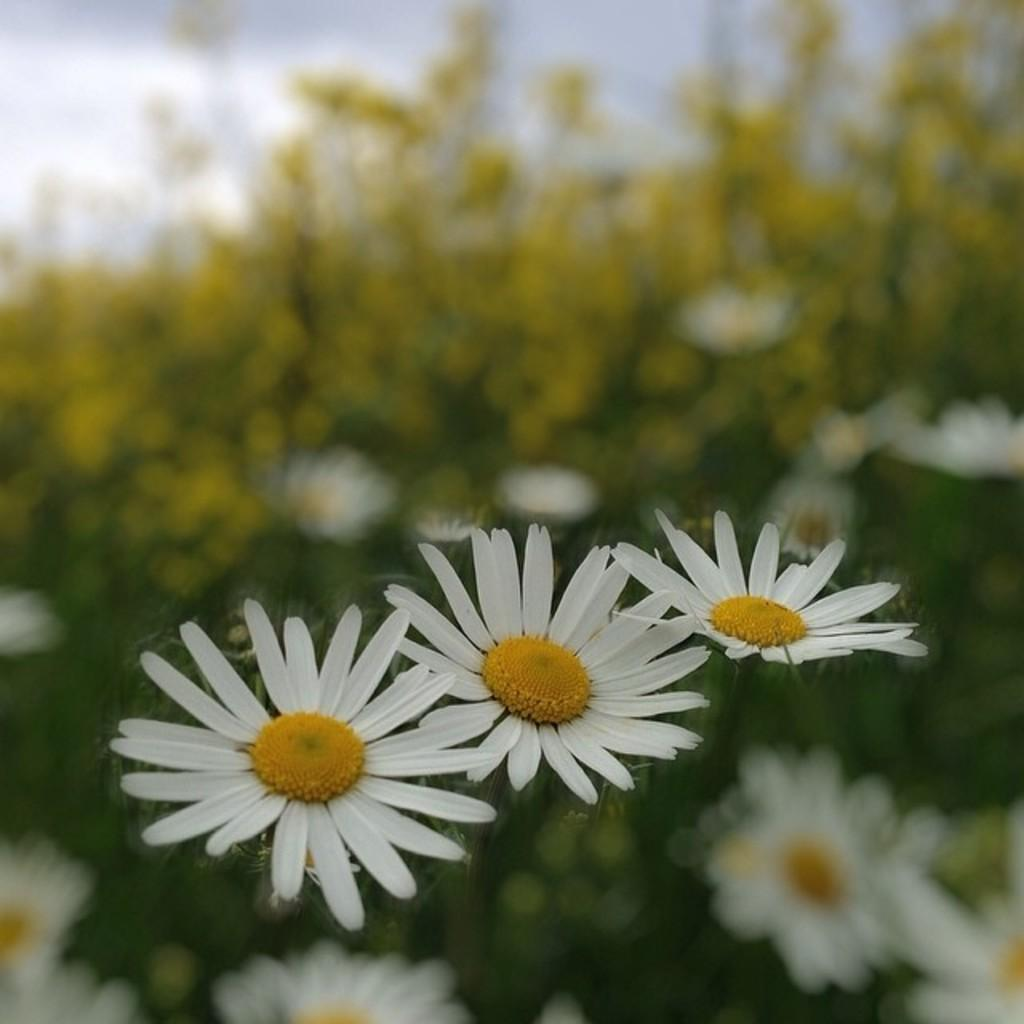What type of objects are present in the image? There are flowers in the image. What colors can be seen in the flowers? The flowers are in white and yellow colors. Can you describe the background of the image? The background of the image is blurred. Where is the wax being used in the image? There is no wax present in the image. What type of flame can be seen in the image? There is no flame present in the image. 